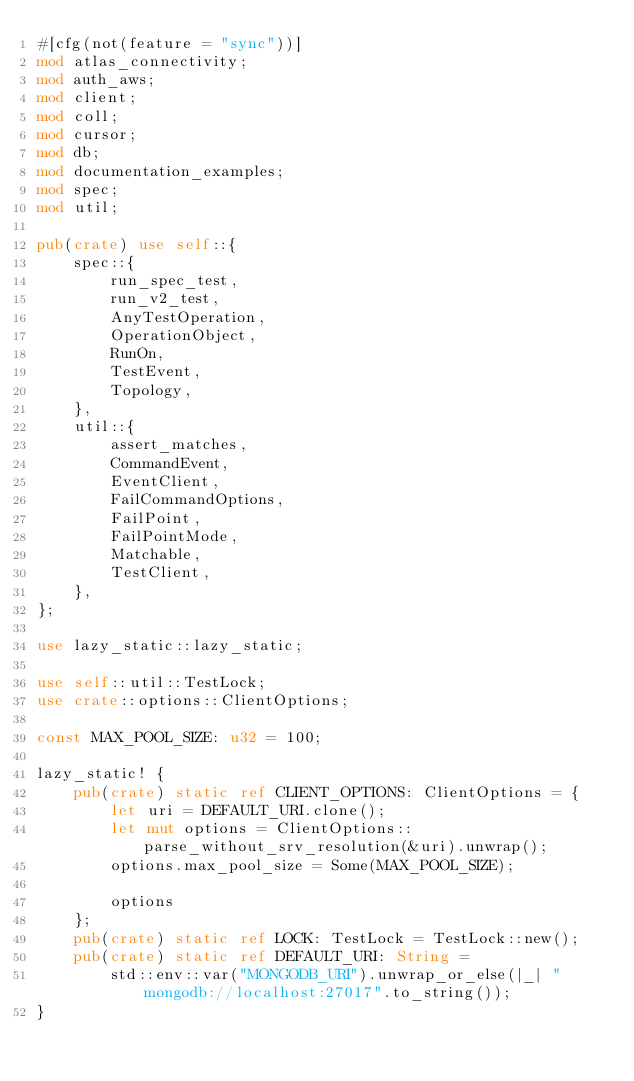Convert code to text. <code><loc_0><loc_0><loc_500><loc_500><_Rust_>#[cfg(not(feature = "sync"))]
mod atlas_connectivity;
mod auth_aws;
mod client;
mod coll;
mod cursor;
mod db;
mod documentation_examples;
mod spec;
mod util;

pub(crate) use self::{
    spec::{
        run_spec_test,
        run_v2_test,
        AnyTestOperation,
        OperationObject,
        RunOn,
        TestEvent,
        Topology,
    },
    util::{
        assert_matches,
        CommandEvent,
        EventClient,
        FailCommandOptions,
        FailPoint,
        FailPointMode,
        Matchable,
        TestClient,
    },
};

use lazy_static::lazy_static;

use self::util::TestLock;
use crate::options::ClientOptions;

const MAX_POOL_SIZE: u32 = 100;

lazy_static! {
    pub(crate) static ref CLIENT_OPTIONS: ClientOptions = {
        let uri = DEFAULT_URI.clone();
        let mut options = ClientOptions::parse_without_srv_resolution(&uri).unwrap();
        options.max_pool_size = Some(MAX_POOL_SIZE);

        options
    };
    pub(crate) static ref LOCK: TestLock = TestLock::new();
    pub(crate) static ref DEFAULT_URI: String =
        std::env::var("MONGODB_URI").unwrap_or_else(|_| "mongodb://localhost:27017".to_string());
}
</code> 